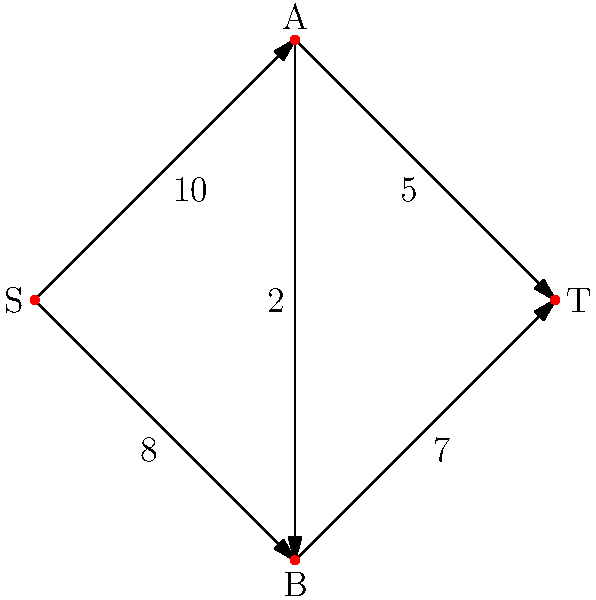In a particle accelerator design, the network flow diagram represents the possible paths for particle beams. The nodes represent beam splitters/combiners, and the edges represent beam paths with their maximum capacities (in arbitrary units). What is the maximum flow that can be achieved from source S to sink T? To solve this maximum flow problem, we'll use the Ford-Fulkerson algorithm:

1. Initialize flow to 0 for all edges.

2. Find an augmenting path from S to T:
   Path 1: S → A → T (min capacity: 5)
   Increase flow by 5, resulting in:
   S → A: 5/10
   A → T: 5/5 (saturated)

3. Find another augmenting path:
   Path 2: S → B → T (min capacity: 7)
   Increase flow by 7, resulting in:
   S → B: 7/8
   B → T: 7/7 (saturated)

4. Find another augmenting path:
   Path 3: S → A → B → T (min capacity: 2)
   Increase flow by 2, resulting in:
   S → A: 7/10
   A → B: 2/2 (saturated)
   B → T: 7/7 (unchanged, still saturated)

5. No more augmenting paths exist, so the algorithm terminates.

6. Sum the flows into T: 5 + 7 = 12

Therefore, the maximum flow from S to T is 12 units.
Answer: 12 units 